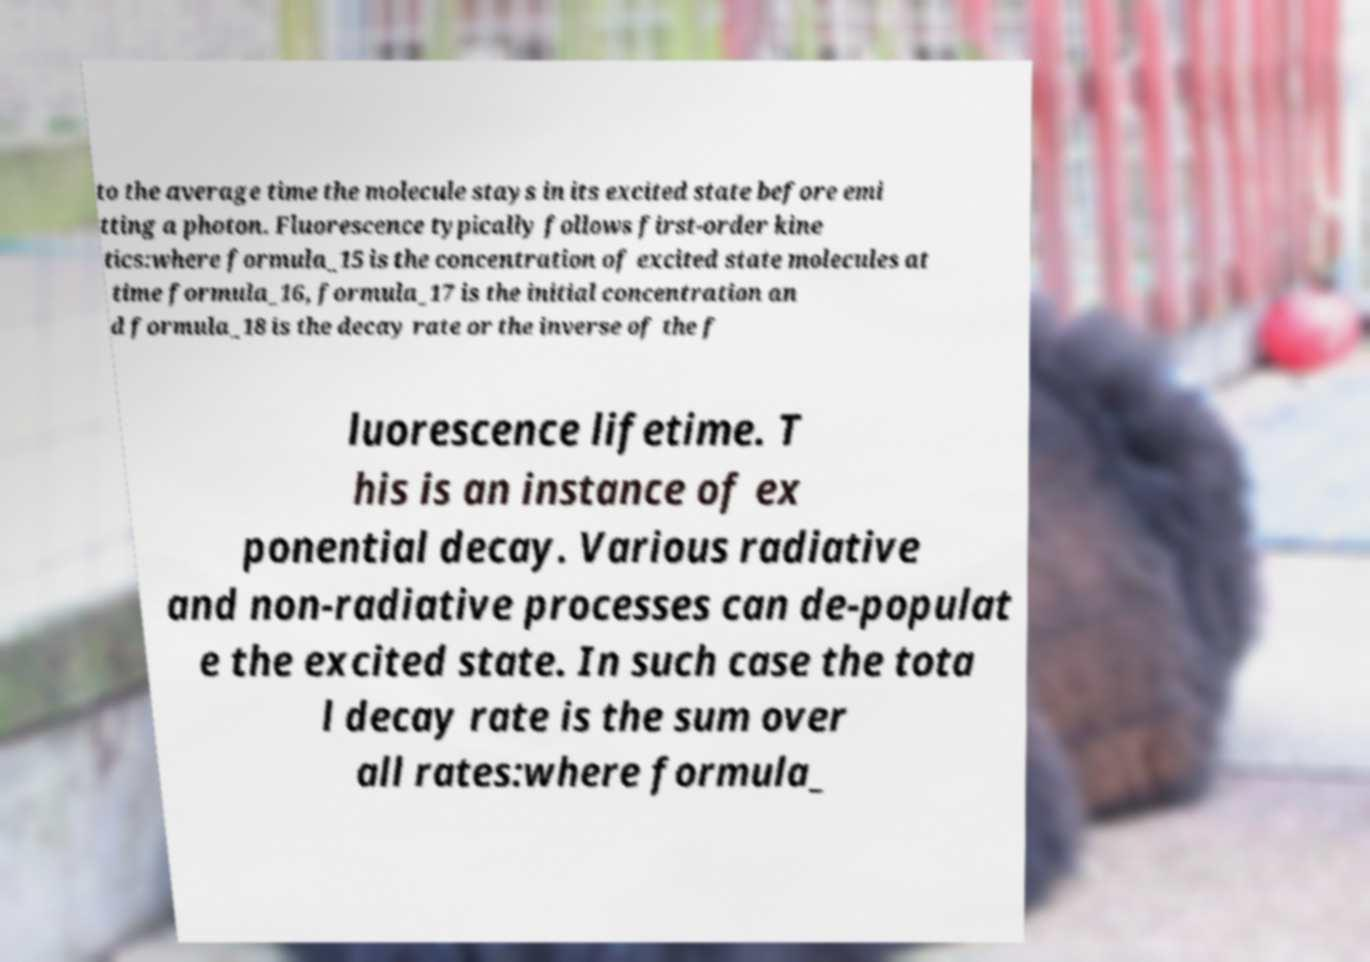Please identify and transcribe the text found in this image. to the average time the molecule stays in its excited state before emi tting a photon. Fluorescence typically follows first-order kine tics:where formula_15 is the concentration of excited state molecules at time formula_16, formula_17 is the initial concentration an d formula_18 is the decay rate or the inverse of the f luorescence lifetime. T his is an instance of ex ponential decay. Various radiative and non-radiative processes can de-populat e the excited state. In such case the tota l decay rate is the sum over all rates:where formula_ 